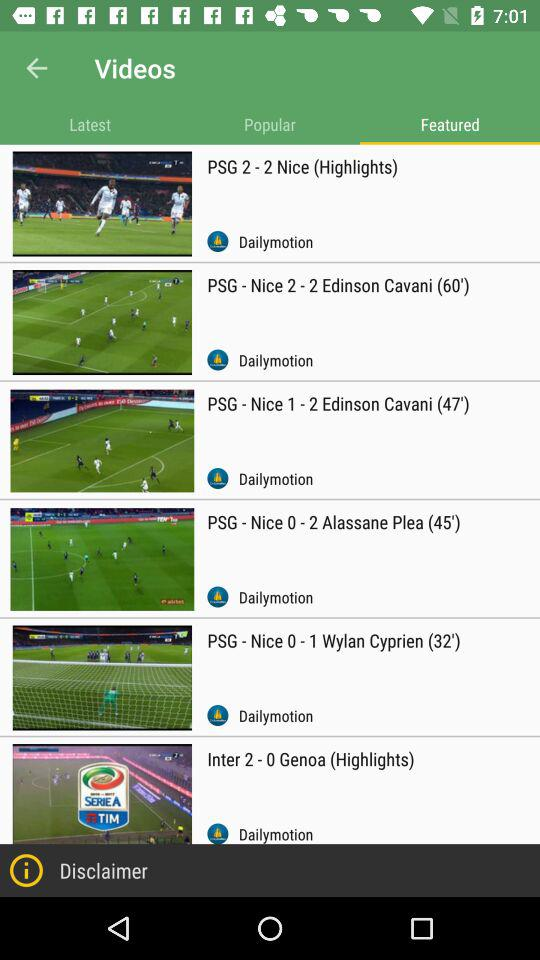What videos are shown on the screen from the above options? The videos are: "PSG 2 - 2 Nice (Highlights)", "PSG - Nice 2 - 2 Edinson Cavani (60')", "PSG - Nice 1 - 2 Edinson Cavani (47')", "PSG - Nice 0 - 2 Alassane Plea (45')", "PSG - Nice 0 - 1 Wylan Cyprien (32')", and "Inter 2 - 0 Genoa (Highlights)". 